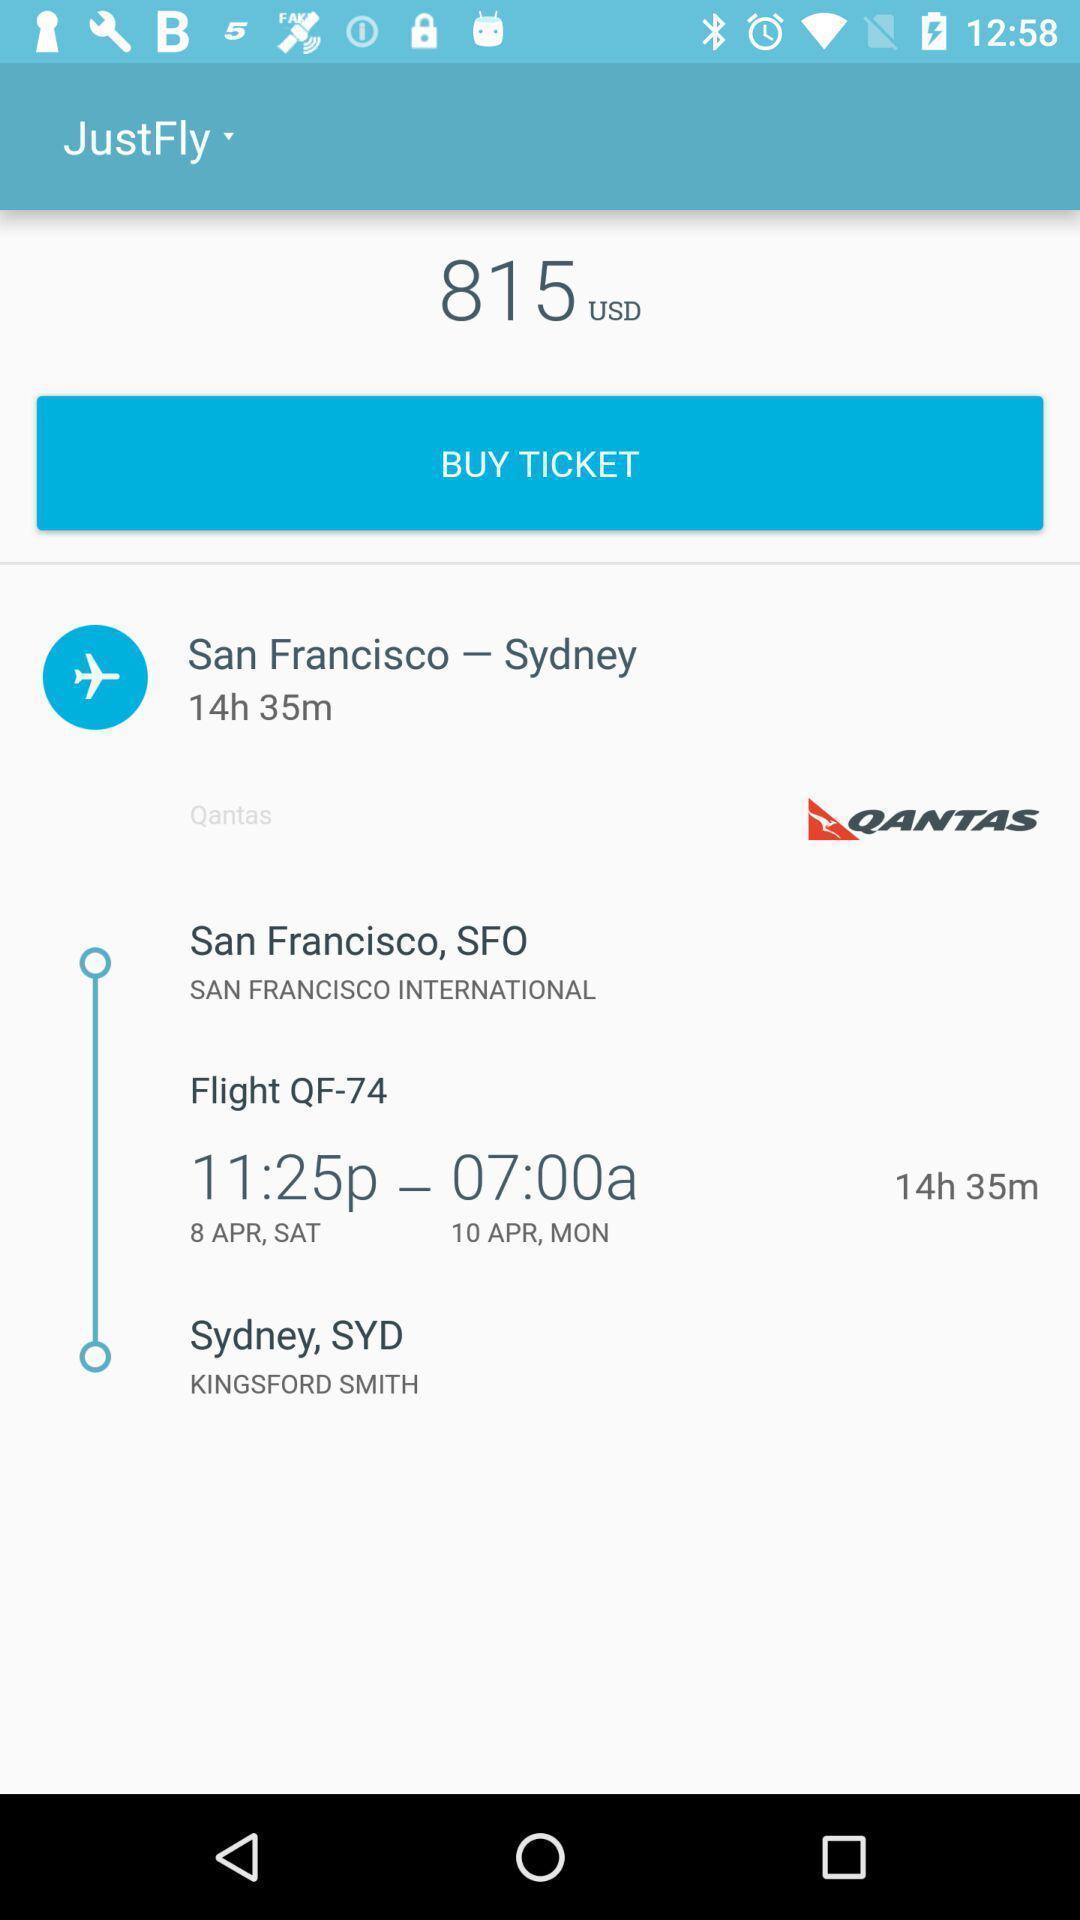Describe the visual elements of this screenshot. Screen displaying the flight ticket information. 